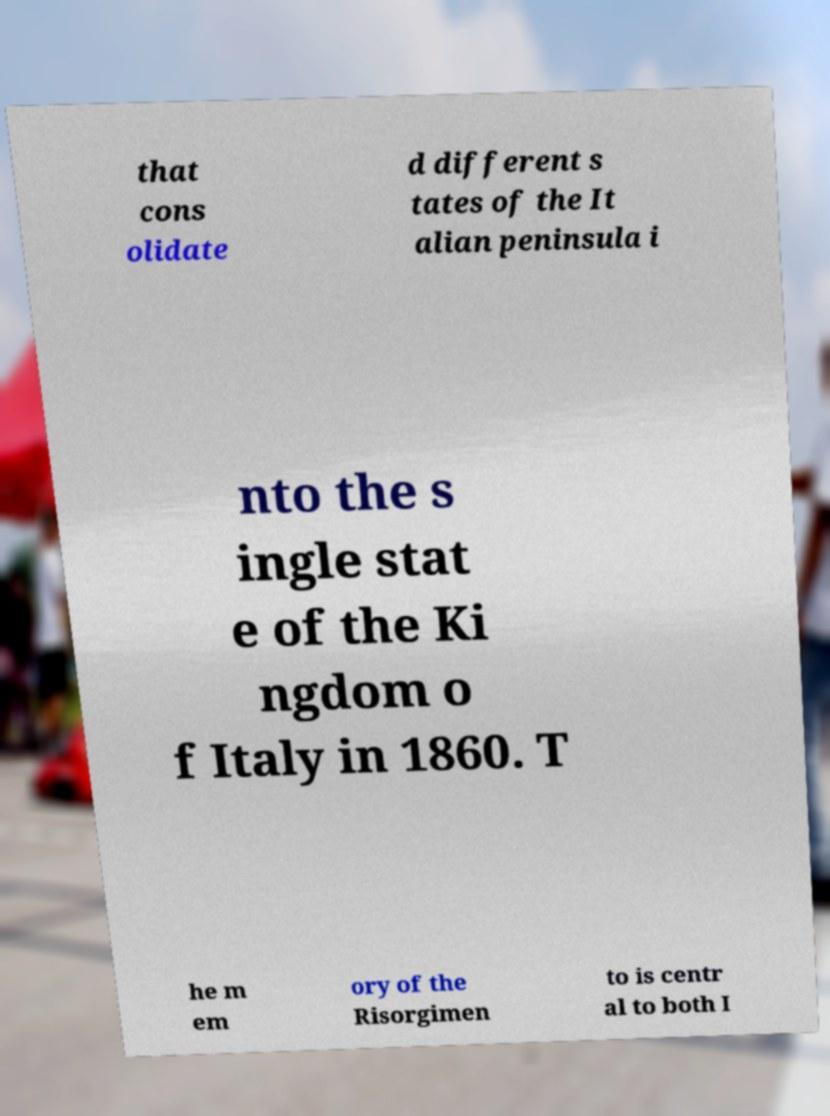Could you assist in decoding the text presented in this image and type it out clearly? that cons olidate d different s tates of the It alian peninsula i nto the s ingle stat e of the Ki ngdom o f Italy in 1860. T he m em ory of the Risorgimen to is centr al to both I 